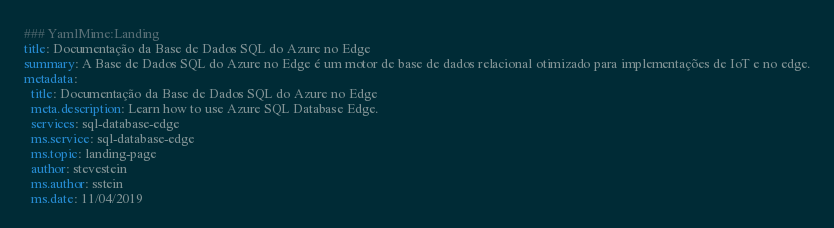<code> <loc_0><loc_0><loc_500><loc_500><_YAML_>### YamlMime:Landing
title: Documentação da Base de Dados SQL do Azure no Edge
summary: A Base de Dados SQL do Azure no Edge é um motor de base de dados relacional otimizado para implementações de IoT e no edge.
metadata:
  title: Documentação da Base de Dados SQL do Azure no Edge
  meta.description: Learn how to use Azure SQL Database Edge.
  services: sql-database-edge
  ms.service: sql-database-edge
  ms.topic: landing-page
  author: stevestein
  ms.author: sstein
  ms.date: 11/04/2019</code> 